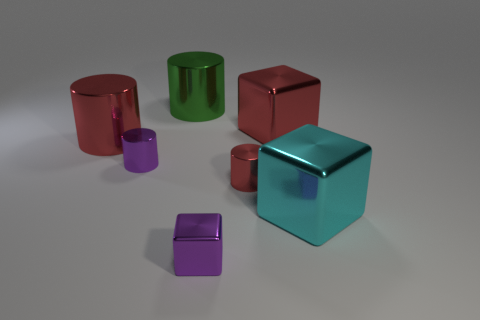There is a green cylinder that is the same material as the cyan block; what size is it?
Give a very brief answer. Large. There is a small metal thing that is in front of the cyan shiny thing; what number of shiny objects are left of it?
Offer a very short reply. 3. Are there any other cyan shiny objects of the same shape as the large cyan object?
Offer a terse response. No. There is a cylinder that is behind the cube behind the purple metal cylinder; what color is it?
Your answer should be compact. Green. Is the number of big blue cubes greater than the number of big green objects?
Keep it short and to the point. No. How many cyan blocks are the same size as the purple shiny cube?
Make the answer very short. 0. Is the material of the purple cylinder the same as the red cylinder on the left side of the small block?
Make the answer very short. Yes. Is the number of tiny purple metallic blocks less than the number of cubes?
Your answer should be very brief. Yes. Are there any other things of the same color as the small block?
Give a very brief answer. Yes. There is a small red thing that is made of the same material as the cyan block; what is its shape?
Provide a short and direct response. Cylinder. 